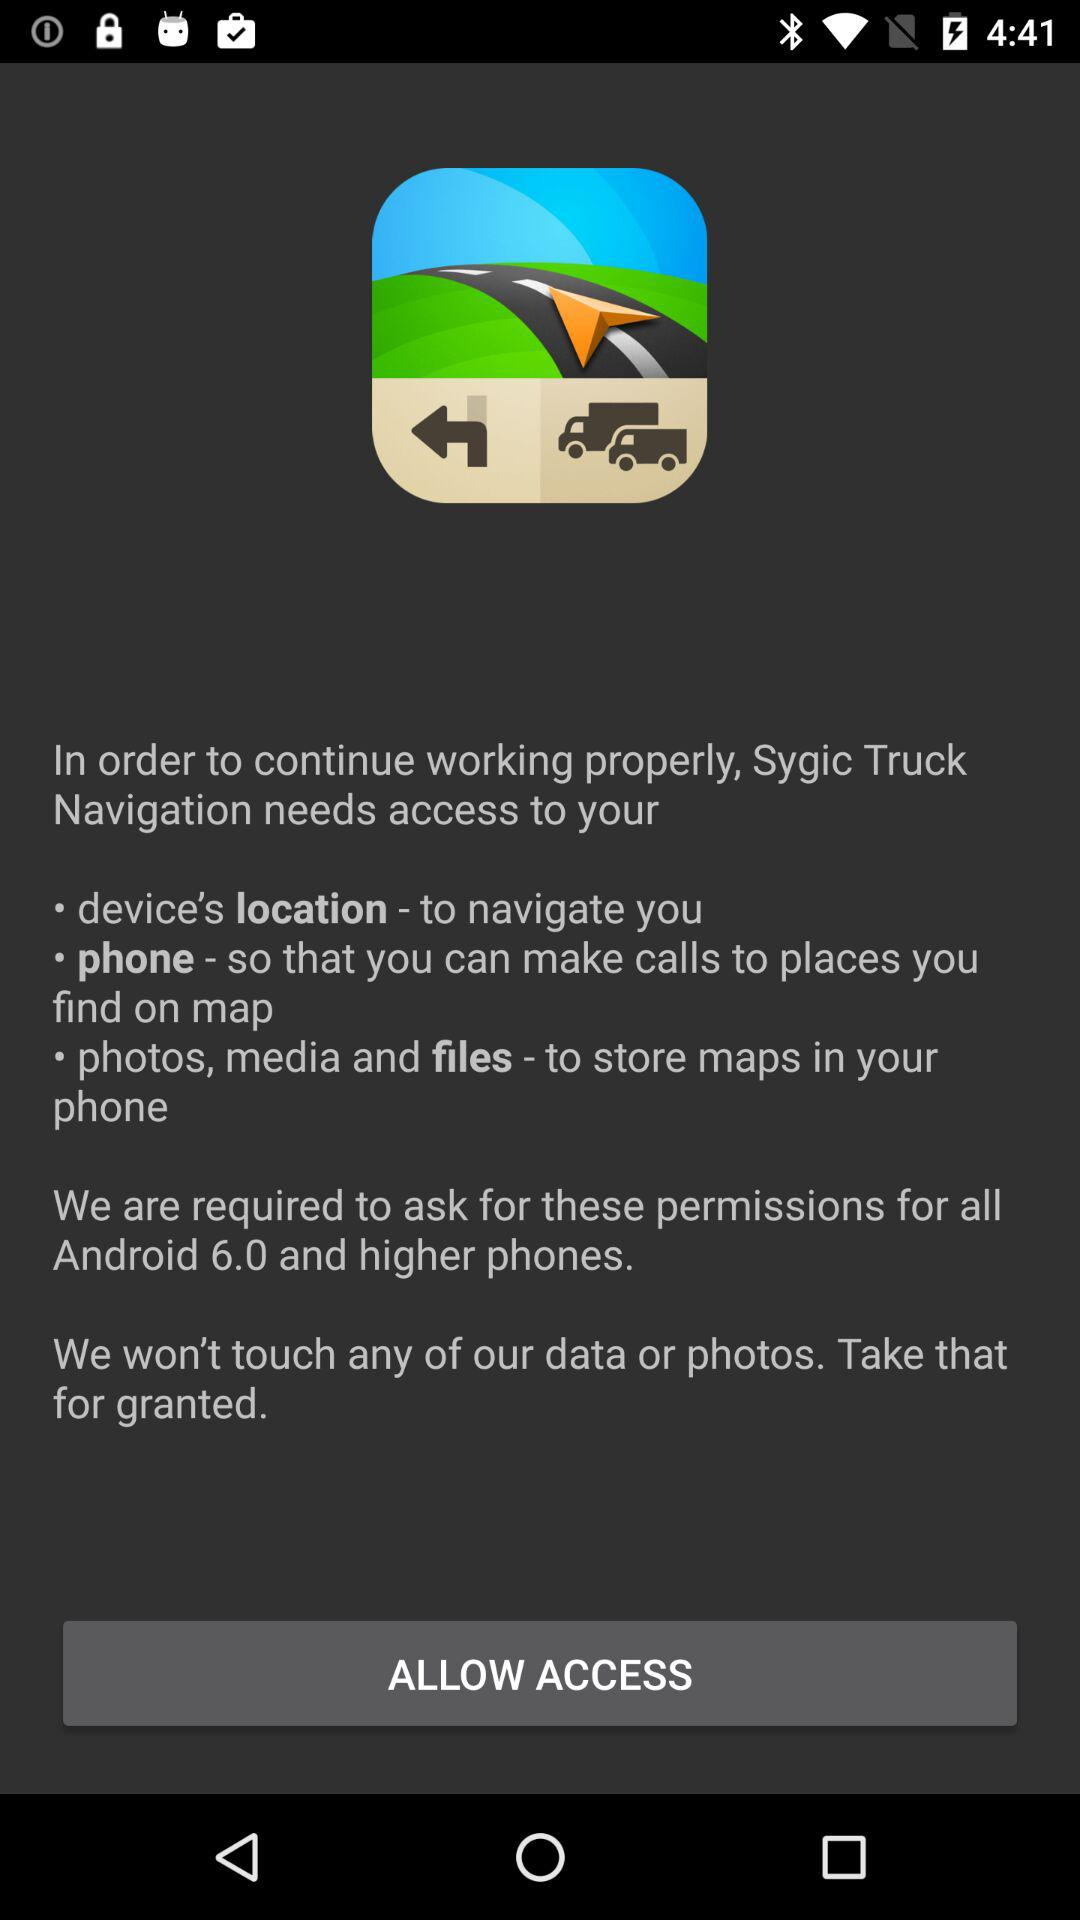What is the Android version? The Android version is 6.0. 